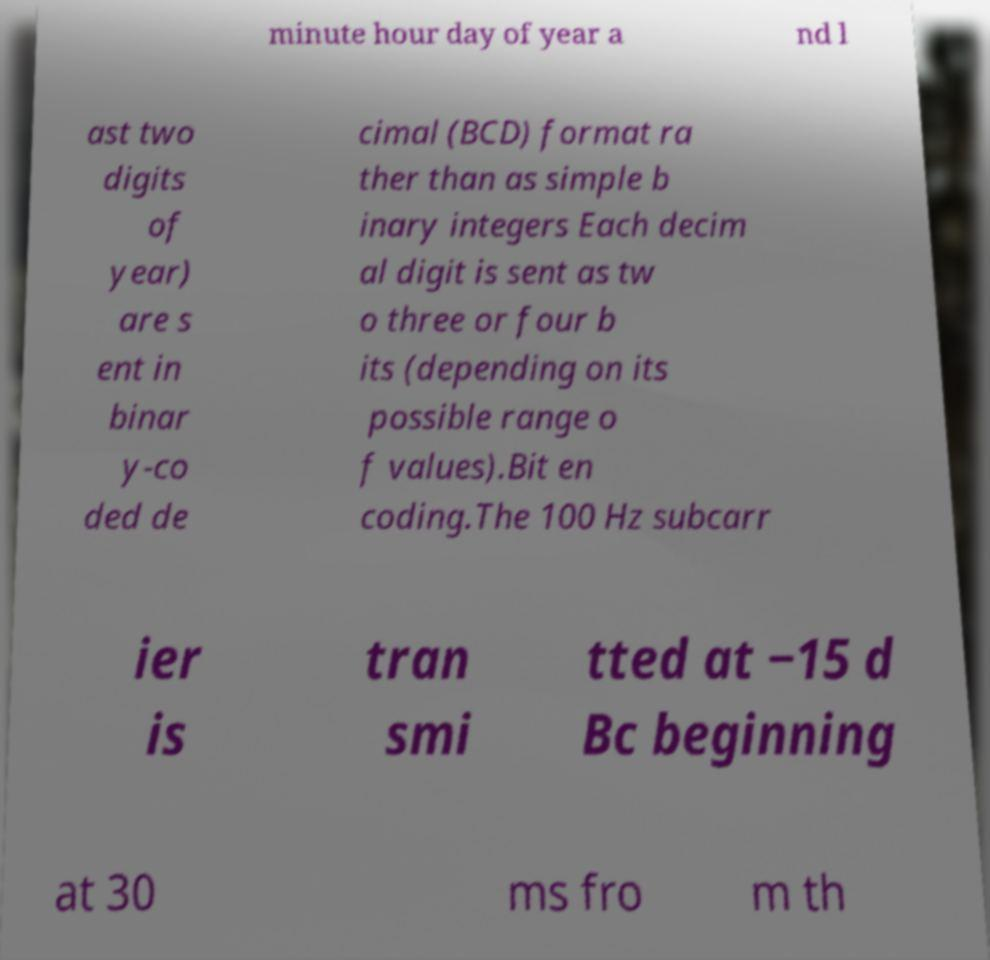Could you assist in decoding the text presented in this image and type it out clearly? minute hour day of year a nd l ast two digits of year) are s ent in binar y-co ded de cimal (BCD) format ra ther than as simple b inary integers Each decim al digit is sent as tw o three or four b its (depending on its possible range o f values).Bit en coding.The 100 Hz subcarr ier is tran smi tted at −15 d Bc beginning at 30 ms fro m th 